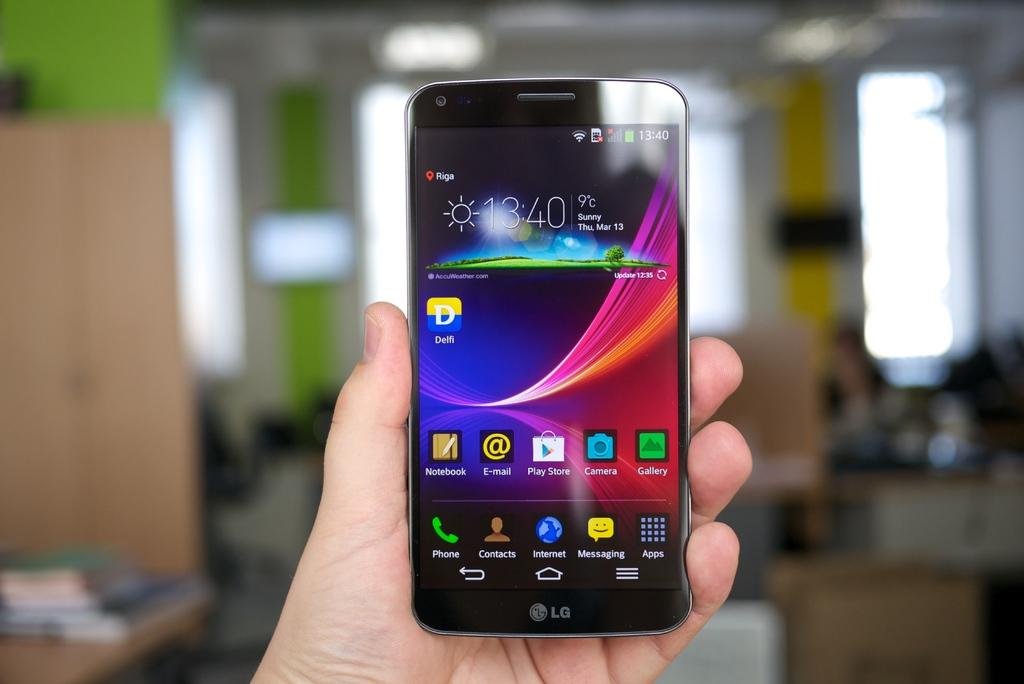What time is on the phone?
Offer a very short reply. 13:40. What is the brand of the phone?
Offer a terse response. Lg. 